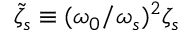Convert formula to latex. <formula><loc_0><loc_0><loc_500><loc_500>\tilde { \zeta } _ { s } \equiv ( \omega _ { 0 } / \omega _ { s } ) ^ { 2 } \zeta _ { s }</formula> 